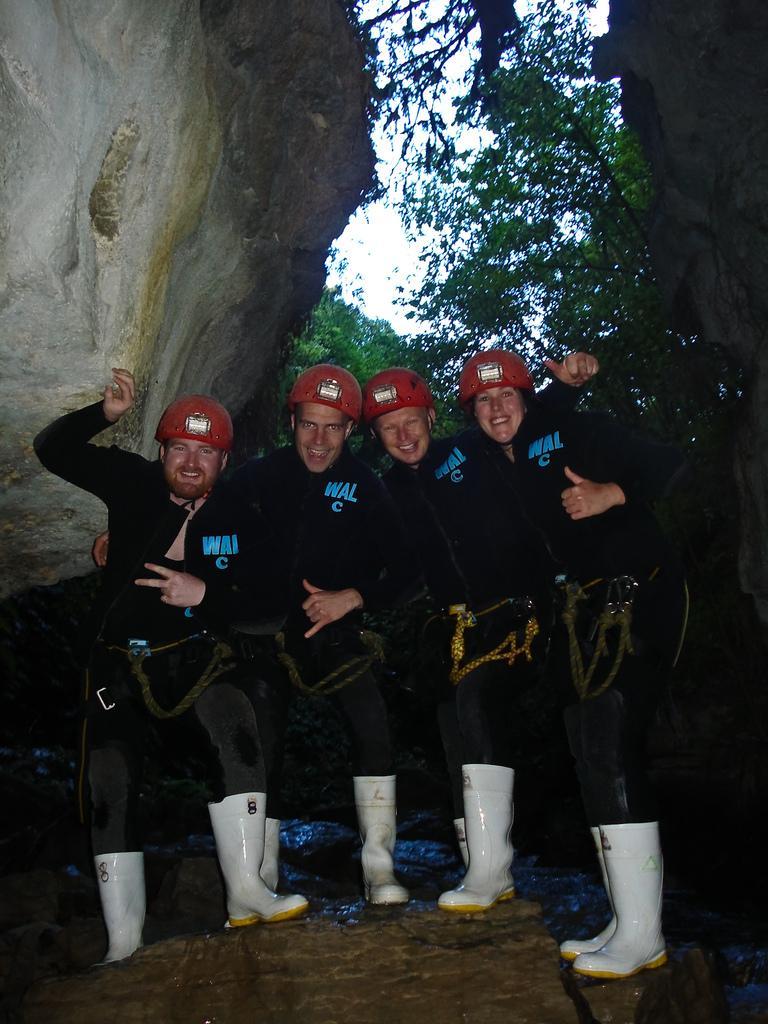Could you give a brief overview of what you see in this image? In this image we can see few people. They are wearing helmets and boots. There are rocks. In the background there are trees and also there is sky. 